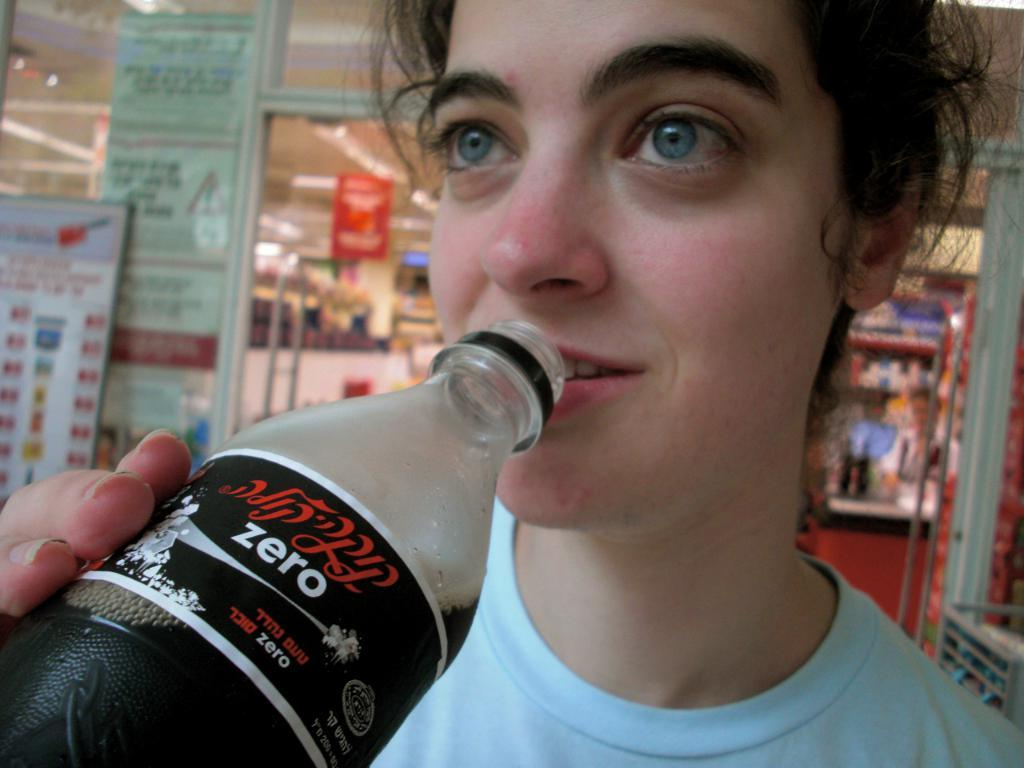Who is present in the image? There is a woman in the image. What is the woman doing in the image? The woman is standing in front of a store. What is the woman holding in the image? The woman is drinking. What type of goldfish can be seen swimming in the image? There are no goldfish present in the image. What type of spoon is the woman using to eat in the image? The woman is drinking, not eating, so there is no spoon present in the image. 